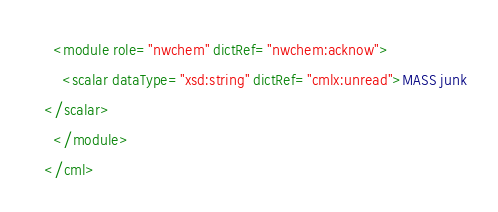Convert code to text. <code><loc_0><loc_0><loc_500><loc_500><_XML_>  <module role="nwchem" dictRef="nwchem:acknow">
    <scalar dataType="xsd:string" dictRef="cmlx:unread">MASS junk
</scalar>
  </module>
</cml>
</code> 